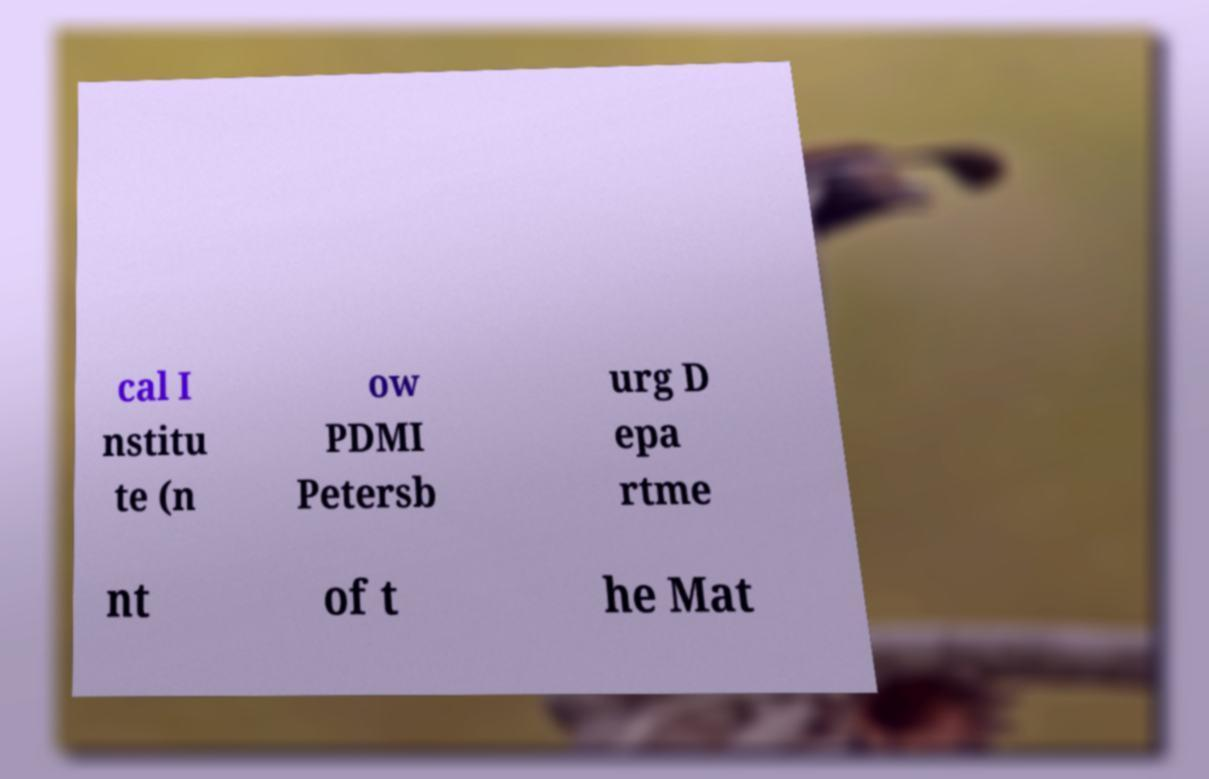Could you extract and type out the text from this image? cal I nstitu te (n ow PDMI Petersb urg D epa rtme nt of t he Mat 